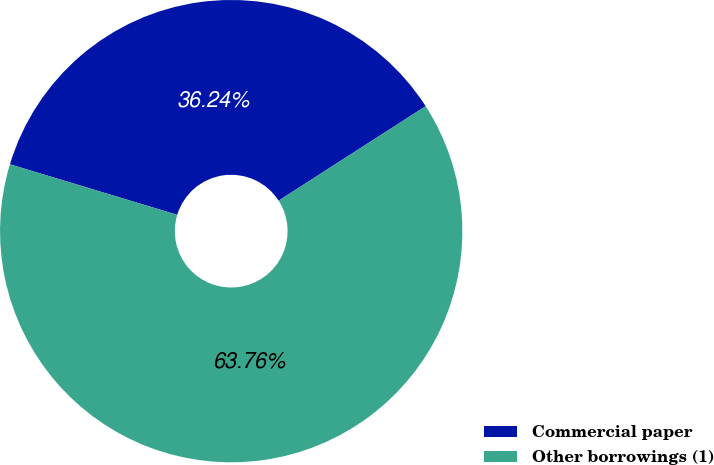Convert chart. <chart><loc_0><loc_0><loc_500><loc_500><pie_chart><fcel>Commercial paper<fcel>Other borrowings (1)<nl><fcel>36.24%<fcel>63.76%<nl></chart> 